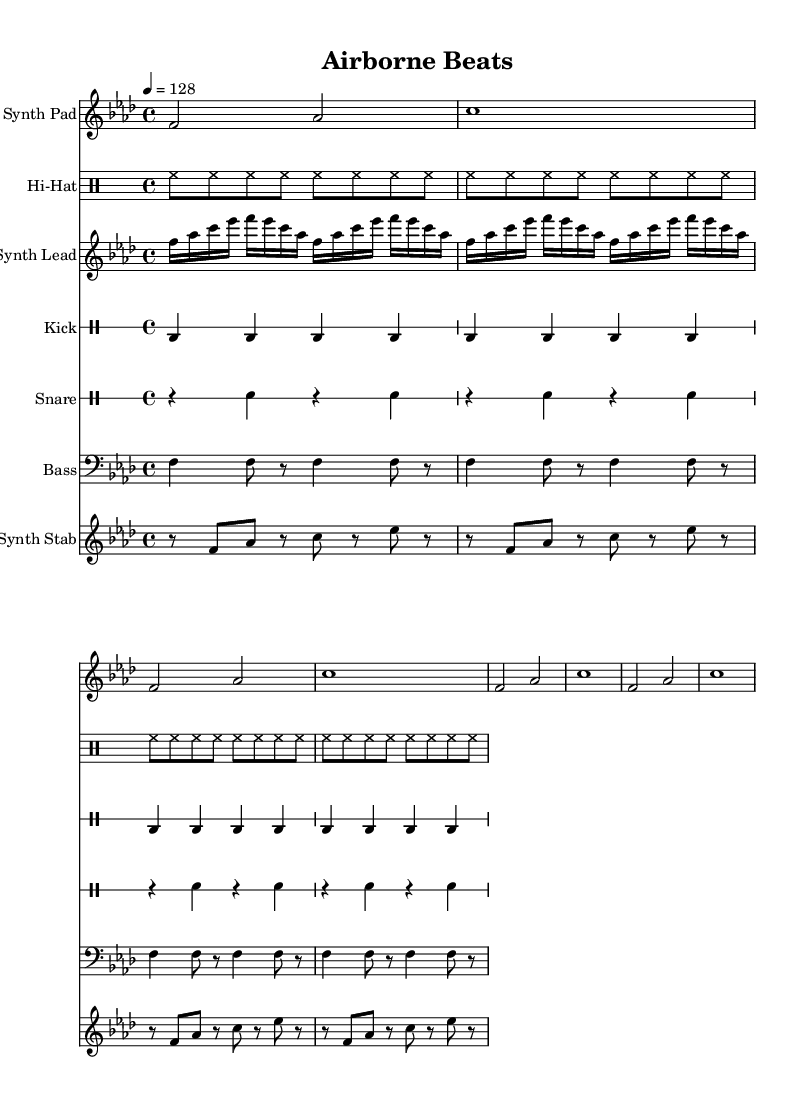What is the key signature of this music? The key signature indicates that the music is in F minor, which has four flats. This can be identified on the left side of the staff where the flats are notated.
Answer: F minor What is the time signature of the music? The time signature is located at the beginning of the score, and it indicates the number of beats in a measure as well as the note value that represents one beat. In this case, it shows 4/4, meaning four beats per measure with a quarter note getting one beat.
Answer: 4/4 What is the tempo marking of the piece? The tempo marking is shown at the beginning of the score as "4 = 128". This indicates that the quarter notes are played at a speed of 128 beats per minute.
Answer: 128 How many measures are in the synth pad section? To find the number of measures in the synth pad section, we look for the vertical bar lines that separate each measure. There are four measures present in the synth pad section of the score.
Answer: 4 What type of percussion is featured prominently in this score? The score includes various percussion elements, but the kick drum is a prominent feature, as it is played consistently in every measure and typically creates a driving rhythm, which is essential in house music.
Answer: Kick drum What is the repeated rhythmic block in the hi-hat part? The hi-hat part consists of a consistent eighth-note rhythm that repeats across all measures. This repetitive pattern is typical in house music to maintain energy and drive throughout the track.
Answer: Eighth notes What kind of synth technique is used in the lead synth? The synth lead utilizes a repeating sixteenth-note motif that presents a catchy and rhythmic element. This technique is common in house music to create hypnotic grooves and engaging melodies.
Answer: Repeating sixteenth-note motif 